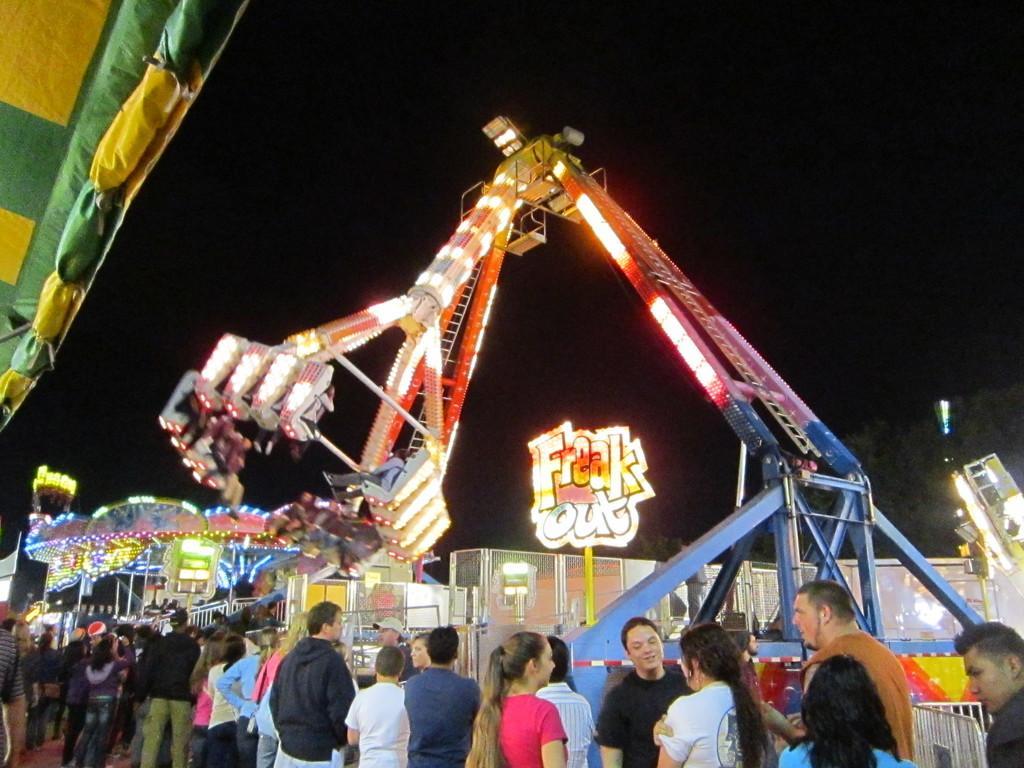Could you give a brief overview of what you see in this image? This picture is taken in an exhibition the people enjoying the rides in the exhibition. 